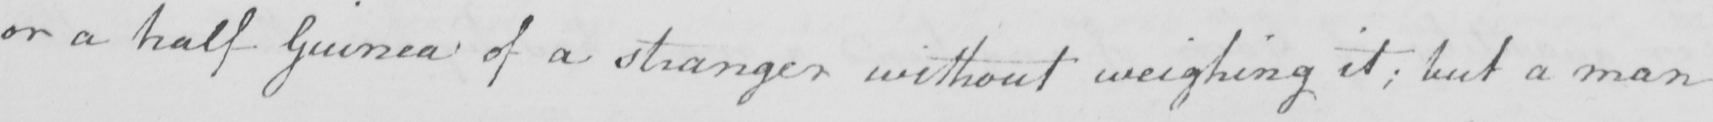What is written in this line of handwriting? or a half Guinea of a stranger without weighing it ; but a man 